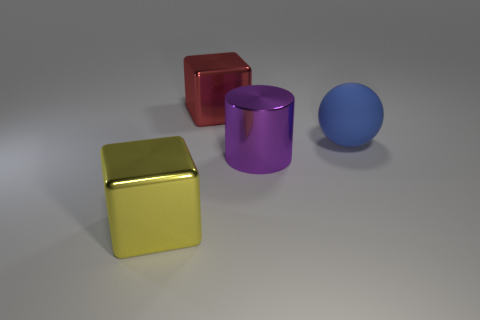Subtract all cyan spheres. Subtract all brown blocks. How many spheres are left? 1 Add 4 cyan metallic things. How many objects exist? 8 Subtract all spheres. How many objects are left? 3 Add 2 big yellow blocks. How many big yellow blocks are left? 3 Add 1 red cubes. How many red cubes exist? 2 Subtract 0 blue blocks. How many objects are left? 4 Subtract all big objects. Subtract all tiny gray matte cylinders. How many objects are left? 0 